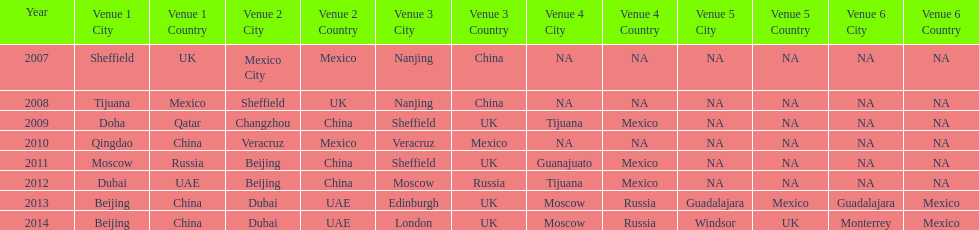What was the last year where tijuana was a venue? 2012. 